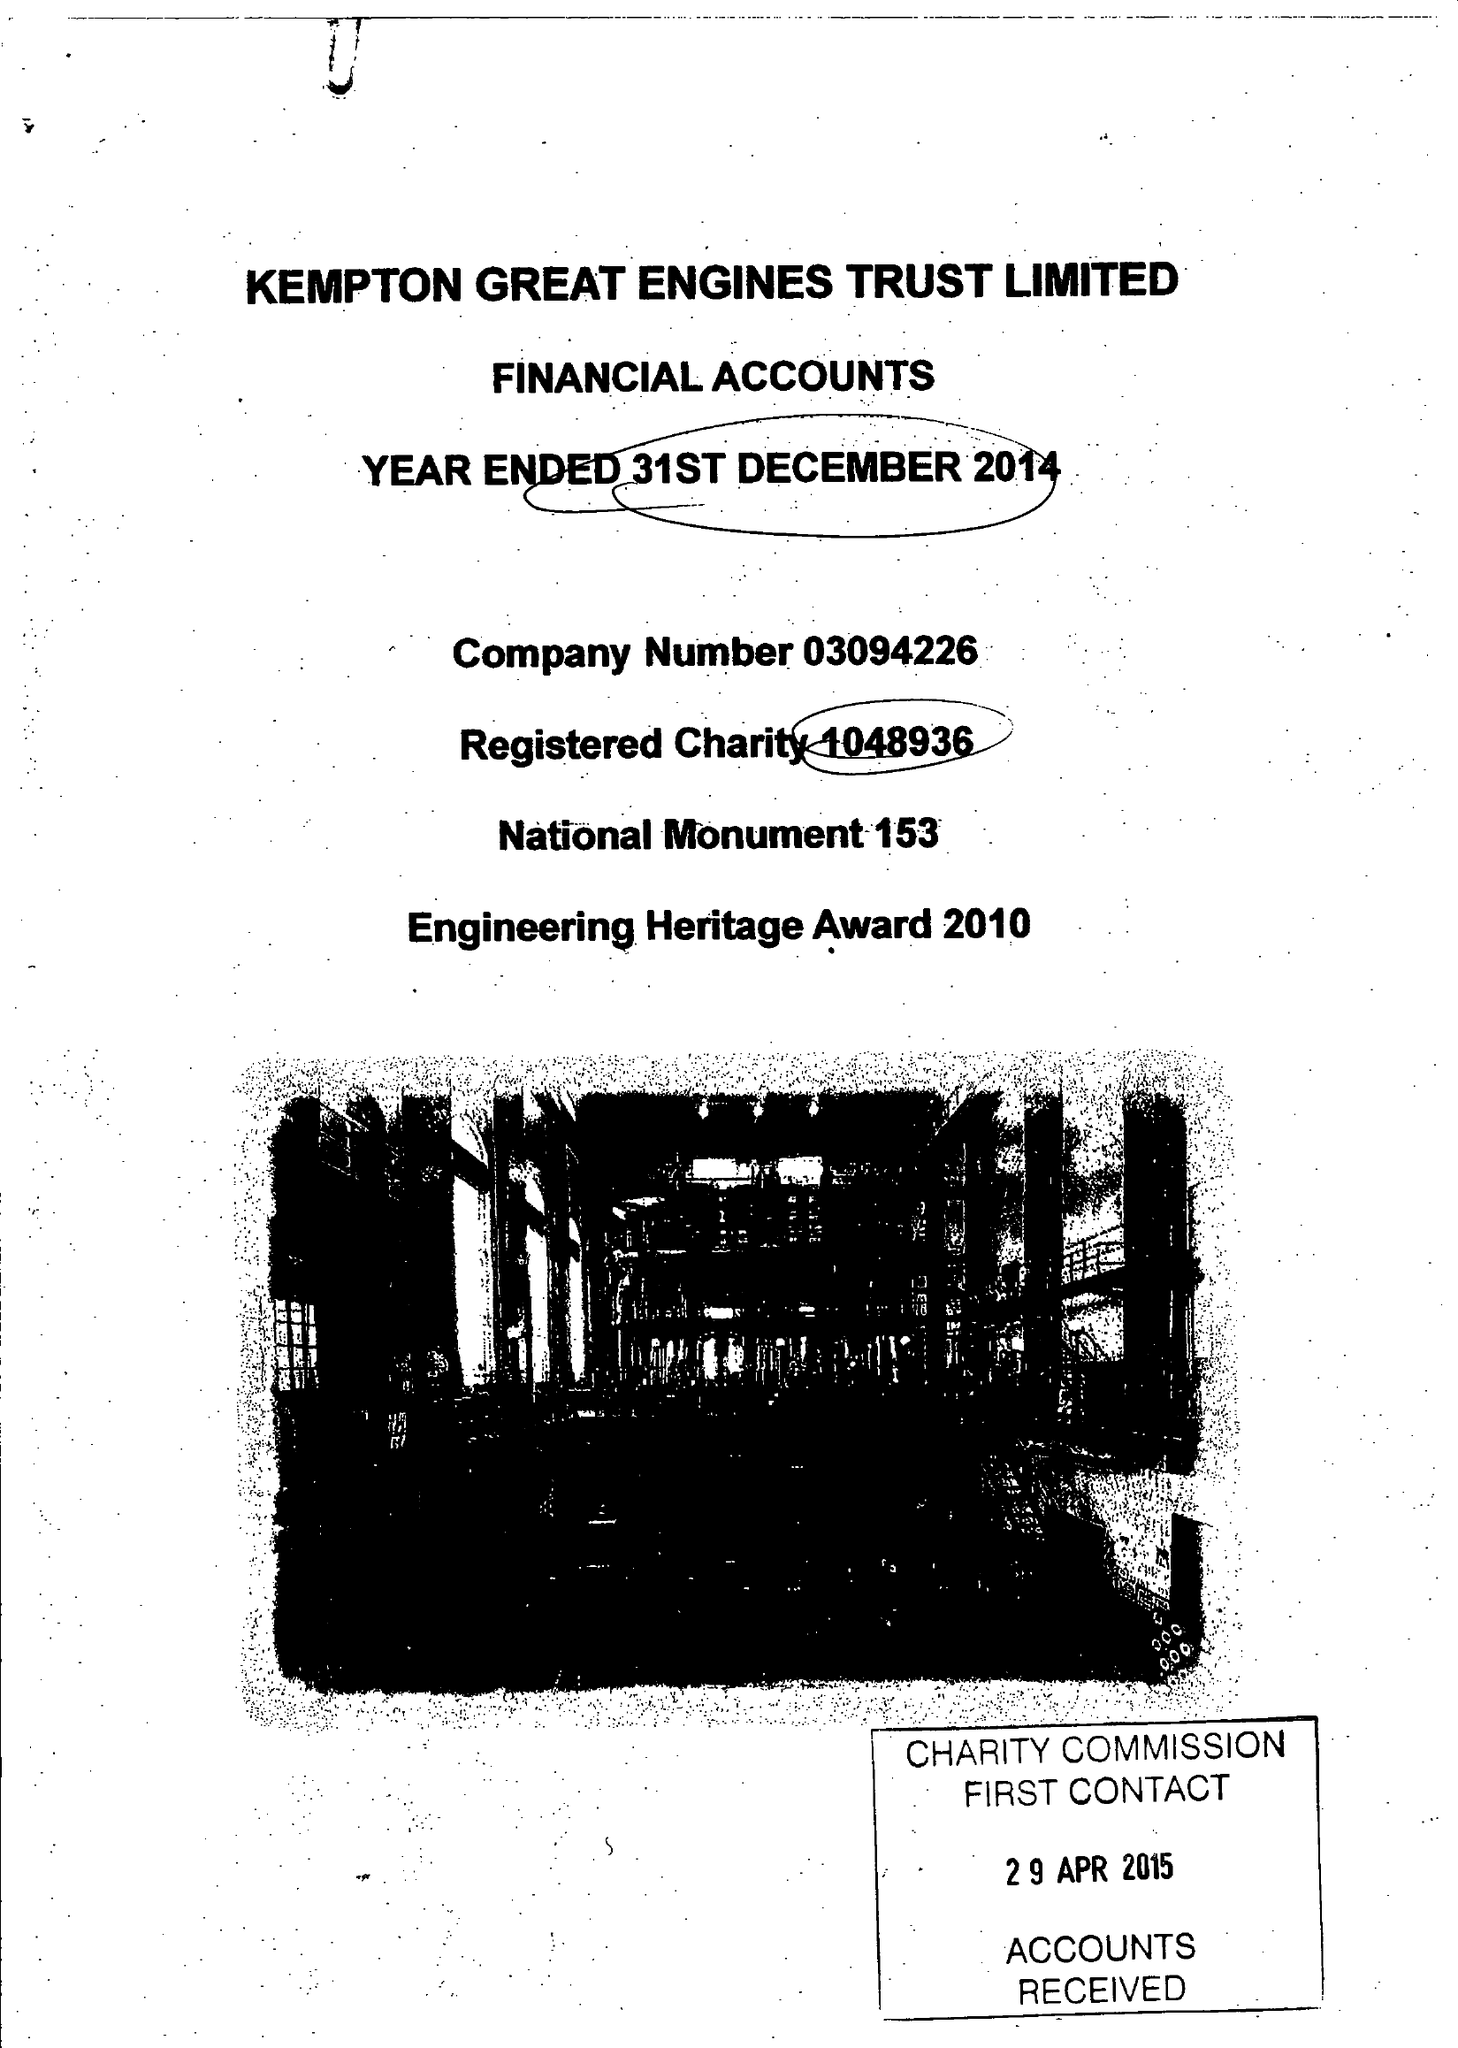What is the value for the report_date?
Answer the question using a single word or phrase. 2014-12-31 